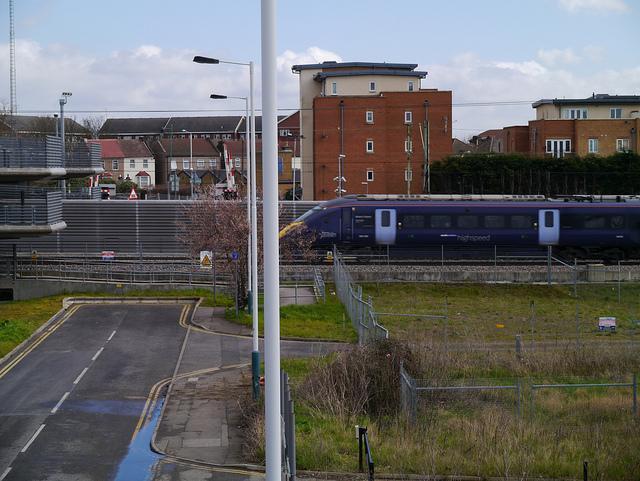How many white lines are on the road?
Give a very brief answer. 6. 